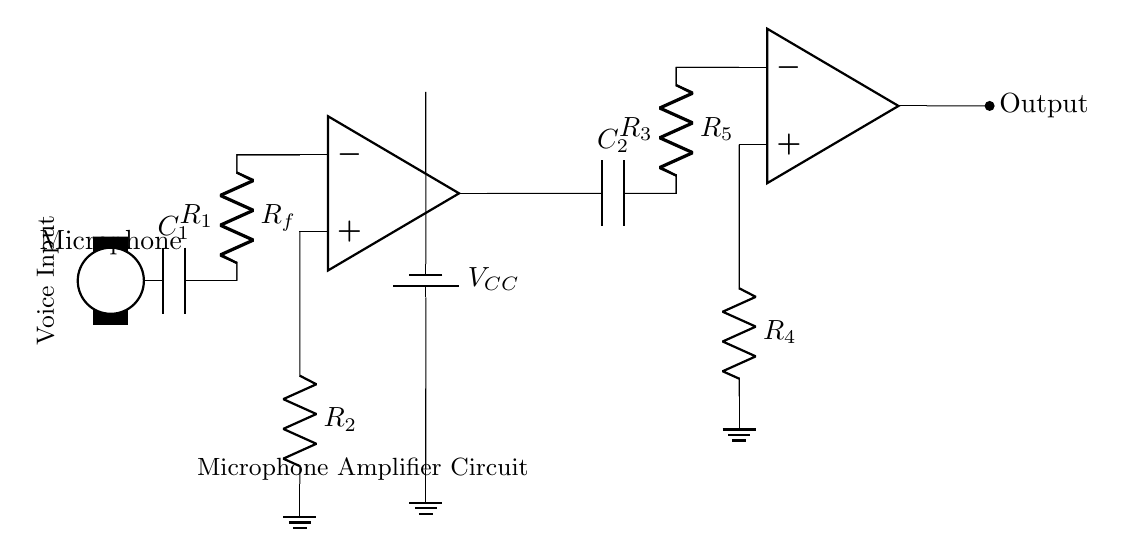What is the type of circuit depicted? The circuit is a microphone amplifier circuit designed to amplify voice signals for recording. The presence of a microphone and operational amplifiers indicates its function as an amplifier.
Answer: Microphone amplifier circuit How many operational amplifiers are used? There are two operational amplifiers shown in the circuit. Each is represented by its own symbol, positioned after the first and second stage of amplification.
Answer: Two What is the role of the capacitor labeled C1? C1 is a coupling capacitor that is responsible for blocking DC voltage while allowing AC signals (like voice) to pass through, which is essential in audio applications to prevent low-frequency noise.
Answer: Coupling What are the components connected to the output of the second operational amplifier? The output of the second operational amplifier is connected to a node (circ) labeled as Output; there are no additional components depicted directly at this output in the diagram.
Answer: Output What is the purpose of the resistor labeled R_f? The resistor R_f functions as a feedback resistor in the first stage amplifier, which helps set the gain of the amplifier by determining how much of the output signal is fed back to the inverting input.
Answer: Gain control What is the power supply voltage in this circuit? The power supply voltage is indicated by the label V_CC and typically represents the positive voltage source that powers the operational amplifiers; however, the exact value is not specified in the diagram.
Answer: Not specified What is the function of the second coupling capacitor C2? C2 serves a similar role to the first coupling capacitor; it allows the amplified AC voice signal to pass while blocking any DC components, ensuring the integrity of the audio signal is maintained for recording purposes.
Answer: Coupling 